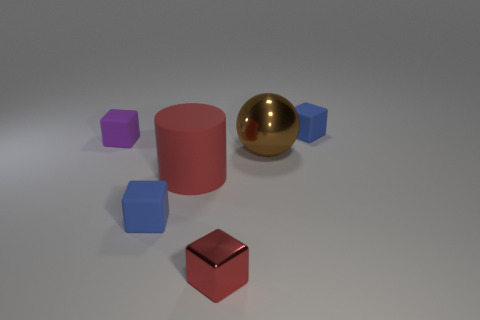What number of matte objects are either small red objects or tiny green cylinders?
Keep it short and to the point. 0. Are there the same number of blue rubber objects to the left of the cylinder and red matte cylinders?
Make the answer very short. Yes. There is a large thing that is left of the red metal thing; is its color the same as the tiny metallic object?
Ensure brevity in your answer.  Yes. There is a tiny object that is on the right side of the red rubber thing and behind the red cylinder; what is its material?
Provide a short and direct response. Rubber. Is there a red rubber thing behind the small blue rubber block that is in front of the big brown thing?
Offer a very short reply. Yes. Does the purple object have the same material as the red cube?
Ensure brevity in your answer.  No. There is a tiny thing that is on the left side of the big rubber cylinder and in front of the purple thing; what is its shape?
Keep it short and to the point. Cube. What size is the blue object that is on the left side of the tiny blue cube behind the big red rubber cylinder?
Provide a short and direct response. Small. How many red objects have the same shape as the big brown thing?
Your answer should be very brief. 0. Do the matte cylinder and the small metallic block have the same color?
Offer a terse response. Yes. 